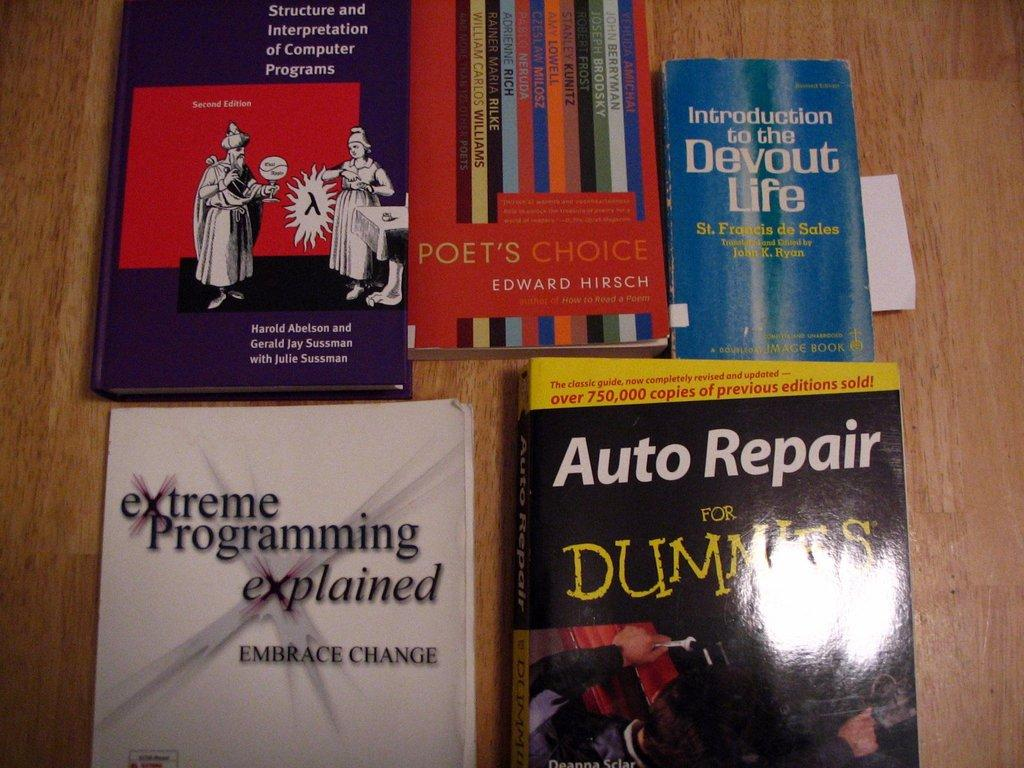<image>
Summarize the visual content of the image. The books on display include Auto Repair for Dummies. 